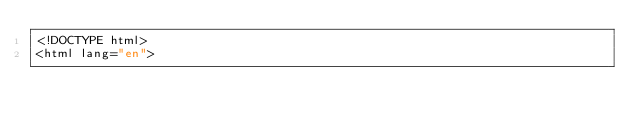<code> <loc_0><loc_0><loc_500><loc_500><_PHP_><!DOCTYPE html>
<html lang="en"></code> 